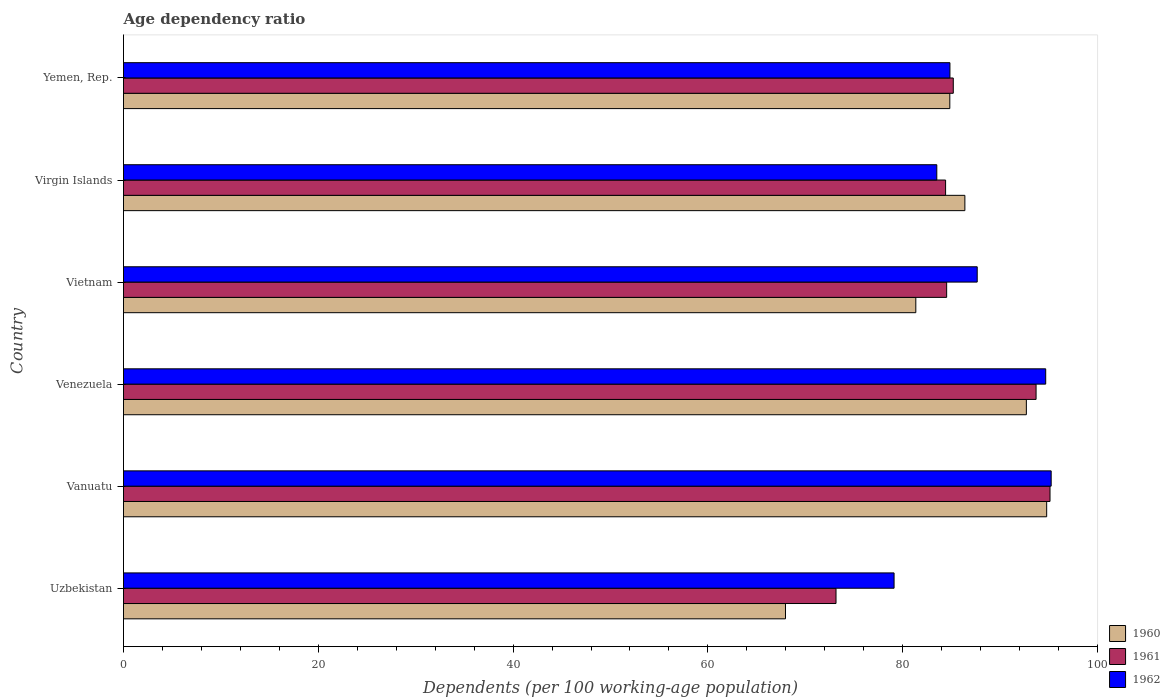How many groups of bars are there?
Your answer should be very brief. 6. Are the number of bars per tick equal to the number of legend labels?
Offer a very short reply. Yes. How many bars are there on the 2nd tick from the top?
Offer a very short reply. 3. What is the label of the 1st group of bars from the top?
Your answer should be very brief. Yemen, Rep. In how many cases, is the number of bars for a given country not equal to the number of legend labels?
Offer a very short reply. 0. What is the age dependency ratio in in 1961 in Venezuela?
Your response must be concise. 93.69. Across all countries, what is the maximum age dependency ratio in in 1961?
Provide a short and direct response. 95.12. Across all countries, what is the minimum age dependency ratio in in 1962?
Ensure brevity in your answer.  79.11. In which country was the age dependency ratio in in 1962 maximum?
Your response must be concise. Vanuatu. In which country was the age dependency ratio in in 1961 minimum?
Keep it short and to the point. Uzbekistan. What is the total age dependency ratio in in 1962 in the graph?
Your answer should be compact. 525.04. What is the difference between the age dependency ratio in in 1961 in Virgin Islands and that in Yemen, Rep.?
Your answer should be very brief. -0.79. What is the difference between the age dependency ratio in in 1961 in Virgin Islands and the age dependency ratio in in 1962 in Yemen, Rep.?
Give a very brief answer. -0.45. What is the average age dependency ratio in in 1962 per country?
Offer a very short reply. 87.51. What is the difference between the age dependency ratio in in 1960 and age dependency ratio in in 1961 in Venezuela?
Your response must be concise. -1. In how many countries, is the age dependency ratio in in 1962 greater than 12 %?
Offer a terse response. 6. What is the ratio of the age dependency ratio in in 1961 in Venezuela to that in Yemen, Rep.?
Offer a very short reply. 1.1. Is the age dependency ratio in in 1961 in Vanuatu less than that in Virgin Islands?
Make the answer very short. No. What is the difference between the highest and the second highest age dependency ratio in in 1961?
Your answer should be compact. 1.43. What is the difference between the highest and the lowest age dependency ratio in in 1960?
Make the answer very short. 26.82. In how many countries, is the age dependency ratio in in 1962 greater than the average age dependency ratio in in 1962 taken over all countries?
Give a very brief answer. 3. What does the 2nd bar from the top in Vietnam represents?
Make the answer very short. 1961. Is it the case that in every country, the sum of the age dependency ratio in in 1961 and age dependency ratio in in 1960 is greater than the age dependency ratio in in 1962?
Provide a short and direct response. Yes. How many bars are there?
Ensure brevity in your answer.  18. Are all the bars in the graph horizontal?
Ensure brevity in your answer.  Yes. What is the difference between two consecutive major ticks on the X-axis?
Provide a short and direct response. 20. Are the values on the major ticks of X-axis written in scientific E-notation?
Make the answer very short. No. Does the graph contain grids?
Your answer should be very brief. No. Where does the legend appear in the graph?
Provide a short and direct response. Bottom right. How are the legend labels stacked?
Provide a succinct answer. Vertical. What is the title of the graph?
Provide a succinct answer. Age dependency ratio. Does "2003" appear as one of the legend labels in the graph?
Make the answer very short. No. What is the label or title of the X-axis?
Offer a terse response. Dependents (per 100 working-age population). What is the Dependents (per 100 working-age population) of 1960 in Uzbekistan?
Make the answer very short. 67.97. What is the Dependents (per 100 working-age population) of 1961 in Uzbekistan?
Ensure brevity in your answer.  73.15. What is the Dependents (per 100 working-age population) in 1962 in Uzbekistan?
Give a very brief answer. 79.11. What is the Dependents (per 100 working-age population) of 1960 in Vanuatu?
Your answer should be very brief. 94.78. What is the Dependents (per 100 working-age population) in 1961 in Vanuatu?
Your answer should be very brief. 95.12. What is the Dependents (per 100 working-age population) of 1962 in Vanuatu?
Offer a very short reply. 95.24. What is the Dependents (per 100 working-age population) of 1960 in Venezuela?
Ensure brevity in your answer.  92.7. What is the Dependents (per 100 working-age population) in 1961 in Venezuela?
Provide a short and direct response. 93.69. What is the Dependents (per 100 working-age population) in 1962 in Venezuela?
Offer a terse response. 94.68. What is the Dependents (per 100 working-age population) in 1960 in Vietnam?
Ensure brevity in your answer.  81.35. What is the Dependents (per 100 working-age population) of 1961 in Vietnam?
Provide a short and direct response. 84.51. What is the Dependents (per 100 working-age population) of 1962 in Vietnam?
Provide a short and direct response. 87.65. What is the Dependents (per 100 working-age population) of 1960 in Virgin Islands?
Provide a succinct answer. 86.38. What is the Dependents (per 100 working-age population) of 1961 in Virgin Islands?
Give a very brief answer. 84.4. What is the Dependents (per 100 working-age population) of 1962 in Virgin Islands?
Your answer should be compact. 83.5. What is the Dependents (per 100 working-age population) in 1960 in Yemen, Rep.?
Offer a terse response. 84.84. What is the Dependents (per 100 working-age population) of 1961 in Yemen, Rep.?
Your response must be concise. 85.19. What is the Dependents (per 100 working-age population) of 1962 in Yemen, Rep.?
Your answer should be very brief. 84.85. Across all countries, what is the maximum Dependents (per 100 working-age population) in 1960?
Your answer should be very brief. 94.78. Across all countries, what is the maximum Dependents (per 100 working-age population) in 1961?
Give a very brief answer. 95.12. Across all countries, what is the maximum Dependents (per 100 working-age population) in 1962?
Keep it short and to the point. 95.24. Across all countries, what is the minimum Dependents (per 100 working-age population) of 1960?
Offer a very short reply. 67.97. Across all countries, what is the minimum Dependents (per 100 working-age population) of 1961?
Make the answer very short. 73.15. Across all countries, what is the minimum Dependents (per 100 working-age population) of 1962?
Your response must be concise. 79.11. What is the total Dependents (per 100 working-age population) of 1960 in the graph?
Offer a terse response. 508.01. What is the total Dependents (per 100 working-age population) in 1961 in the graph?
Give a very brief answer. 516.08. What is the total Dependents (per 100 working-age population) in 1962 in the graph?
Your answer should be compact. 525.04. What is the difference between the Dependents (per 100 working-age population) in 1960 in Uzbekistan and that in Vanuatu?
Keep it short and to the point. -26.82. What is the difference between the Dependents (per 100 working-age population) of 1961 in Uzbekistan and that in Vanuatu?
Keep it short and to the point. -21.97. What is the difference between the Dependents (per 100 working-age population) in 1962 in Uzbekistan and that in Vanuatu?
Your answer should be compact. -16.13. What is the difference between the Dependents (per 100 working-age population) in 1960 in Uzbekistan and that in Venezuela?
Your answer should be compact. -24.73. What is the difference between the Dependents (per 100 working-age population) in 1961 in Uzbekistan and that in Venezuela?
Your response must be concise. -20.54. What is the difference between the Dependents (per 100 working-age population) in 1962 in Uzbekistan and that in Venezuela?
Offer a terse response. -15.57. What is the difference between the Dependents (per 100 working-age population) in 1960 in Uzbekistan and that in Vietnam?
Keep it short and to the point. -13.38. What is the difference between the Dependents (per 100 working-age population) in 1961 in Uzbekistan and that in Vietnam?
Make the answer very short. -11.36. What is the difference between the Dependents (per 100 working-age population) of 1962 in Uzbekistan and that in Vietnam?
Offer a terse response. -8.54. What is the difference between the Dependents (per 100 working-age population) in 1960 in Uzbekistan and that in Virgin Islands?
Provide a short and direct response. -18.42. What is the difference between the Dependents (per 100 working-age population) in 1961 in Uzbekistan and that in Virgin Islands?
Your answer should be very brief. -11.25. What is the difference between the Dependents (per 100 working-age population) in 1962 in Uzbekistan and that in Virgin Islands?
Offer a very short reply. -4.39. What is the difference between the Dependents (per 100 working-age population) of 1960 in Uzbekistan and that in Yemen, Rep.?
Your answer should be very brief. -16.87. What is the difference between the Dependents (per 100 working-age population) in 1961 in Uzbekistan and that in Yemen, Rep.?
Provide a short and direct response. -12.04. What is the difference between the Dependents (per 100 working-age population) in 1962 in Uzbekistan and that in Yemen, Rep.?
Provide a short and direct response. -5.74. What is the difference between the Dependents (per 100 working-age population) of 1960 in Vanuatu and that in Venezuela?
Your answer should be compact. 2.08. What is the difference between the Dependents (per 100 working-age population) of 1961 in Vanuatu and that in Venezuela?
Provide a succinct answer. 1.43. What is the difference between the Dependents (per 100 working-age population) of 1962 in Vanuatu and that in Venezuela?
Give a very brief answer. 0.56. What is the difference between the Dependents (per 100 working-age population) of 1960 in Vanuatu and that in Vietnam?
Keep it short and to the point. 13.43. What is the difference between the Dependents (per 100 working-age population) of 1961 in Vanuatu and that in Vietnam?
Keep it short and to the point. 10.61. What is the difference between the Dependents (per 100 working-age population) of 1962 in Vanuatu and that in Vietnam?
Provide a short and direct response. 7.59. What is the difference between the Dependents (per 100 working-age population) of 1960 in Vanuatu and that in Virgin Islands?
Make the answer very short. 8.4. What is the difference between the Dependents (per 100 working-age population) of 1961 in Vanuatu and that in Virgin Islands?
Your response must be concise. 10.72. What is the difference between the Dependents (per 100 working-age population) in 1962 in Vanuatu and that in Virgin Islands?
Offer a terse response. 11.74. What is the difference between the Dependents (per 100 working-age population) in 1960 in Vanuatu and that in Yemen, Rep.?
Your answer should be compact. 9.94. What is the difference between the Dependents (per 100 working-age population) in 1961 in Vanuatu and that in Yemen, Rep.?
Your response must be concise. 9.93. What is the difference between the Dependents (per 100 working-age population) in 1962 in Vanuatu and that in Yemen, Rep.?
Offer a terse response. 10.39. What is the difference between the Dependents (per 100 working-age population) of 1960 in Venezuela and that in Vietnam?
Your response must be concise. 11.35. What is the difference between the Dependents (per 100 working-age population) of 1961 in Venezuela and that in Vietnam?
Your answer should be very brief. 9.18. What is the difference between the Dependents (per 100 working-age population) of 1962 in Venezuela and that in Vietnam?
Your answer should be very brief. 7.03. What is the difference between the Dependents (per 100 working-age population) in 1960 in Venezuela and that in Virgin Islands?
Your response must be concise. 6.31. What is the difference between the Dependents (per 100 working-age population) of 1961 in Venezuela and that in Virgin Islands?
Your response must be concise. 9.29. What is the difference between the Dependents (per 100 working-age population) in 1962 in Venezuela and that in Virgin Islands?
Provide a succinct answer. 11.18. What is the difference between the Dependents (per 100 working-age population) of 1960 in Venezuela and that in Yemen, Rep.?
Provide a short and direct response. 7.86. What is the difference between the Dependents (per 100 working-age population) in 1961 in Venezuela and that in Yemen, Rep.?
Make the answer very short. 8.5. What is the difference between the Dependents (per 100 working-age population) of 1962 in Venezuela and that in Yemen, Rep.?
Provide a short and direct response. 9.83. What is the difference between the Dependents (per 100 working-age population) of 1960 in Vietnam and that in Virgin Islands?
Make the answer very short. -5.04. What is the difference between the Dependents (per 100 working-age population) of 1961 in Vietnam and that in Virgin Islands?
Give a very brief answer. 0.11. What is the difference between the Dependents (per 100 working-age population) of 1962 in Vietnam and that in Virgin Islands?
Keep it short and to the point. 4.15. What is the difference between the Dependents (per 100 working-age population) of 1960 in Vietnam and that in Yemen, Rep.?
Your answer should be very brief. -3.49. What is the difference between the Dependents (per 100 working-age population) in 1961 in Vietnam and that in Yemen, Rep.?
Provide a succinct answer. -0.68. What is the difference between the Dependents (per 100 working-age population) of 1962 in Vietnam and that in Yemen, Rep.?
Offer a very short reply. 2.8. What is the difference between the Dependents (per 100 working-age population) in 1960 in Virgin Islands and that in Yemen, Rep.?
Provide a succinct answer. 1.55. What is the difference between the Dependents (per 100 working-age population) in 1961 in Virgin Islands and that in Yemen, Rep.?
Provide a succinct answer. -0.79. What is the difference between the Dependents (per 100 working-age population) in 1962 in Virgin Islands and that in Yemen, Rep.?
Provide a short and direct response. -1.35. What is the difference between the Dependents (per 100 working-age population) of 1960 in Uzbekistan and the Dependents (per 100 working-age population) of 1961 in Vanuatu?
Give a very brief answer. -27.16. What is the difference between the Dependents (per 100 working-age population) of 1960 in Uzbekistan and the Dependents (per 100 working-age population) of 1962 in Vanuatu?
Give a very brief answer. -27.28. What is the difference between the Dependents (per 100 working-age population) of 1961 in Uzbekistan and the Dependents (per 100 working-age population) of 1962 in Vanuatu?
Ensure brevity in your answer.  -22.09. What is the difference between the Dependents (per 100 working-age population) in 1960 in Uzbekistan and the Dependents (per 100 working-age population) in 1961 in Venezuela?
Give a very brief answer. -25.73. What is the difference between the Dependents (per 100 working-age population) in 1960 in Uzbekistan and the Dependents (per 100 working-age population) in 1962 in Venezuela?
Provide a short and direct response. -26.72. What is the difference between the Dependents (per 100 working-age population) in 1961 in Uzbekistan and the Dependents (per 100 working-age population) in 1962 in Venezuela?
Keep it short and to the point. -21.53. What is the difference between the Dependents (per 100 working-age population) in 1960 in Uzbekistan and the Dependents (per 100 working-age population) in 1961 in Vietnam?
Offer a terse response. -16.55. What is the difference between the Dependents (per 100 working-age population) in 1960 in Uzbekistan and the Dependents (per 100 working-age population) in 1962 in Vietnam?
Ensure brevity in your answer.  -19.68. What is the difference between the Dependents (per 100 working-age population) in 1961 in Uzbekistan and the Dependents (per 100 working-age population) in 1962 in Vietnam?
Offer a very short reply. -14.5. What is the difference between the Dependents (per 100 working-age population) of 1960 in Uzbekistan and the Dependents (per 100 working-age population) of 1961 in Virgin Islands?
Provide a short and direct response. -16.44. What is the difference between the Dependents (per 100 working-age population) in 1960 in Uzbekistan and the Dependents (per 100 working-age population) in 1962 in Virgin Islands?
Provide a short and direct response. -15.53. What is the difference between the Dependents (per 100 working-age population) of 1961 in Uzbekistan and the Dependents (per 100 working-age population) of 1962 in Virgin Islands?
Give a very brief answer. -10.35. What is the difference between the Dependents (per 100 working-age population) of 1960 in Uzbekistan and the Dependents (per 100 working-age population) of 1961 in Yemen, Rep.?
Provide a succinct answer. -17.23. What is the difference between the Dependents (per 100 working-age population) in 1960 in Uzbekistan and the Dependents (per 100 working-age population) in 1962 in Yemen, Rep.?
Your response must be concise. -16.89. What is the difference between the Dependents (per 100 working-age population) of 1961 in Uzbekistan and the Dependents (per 100 working-age population) of 1962 in Yemen, Rep.?
Give a very brief answer. -11.7. What is the difference between the Dependents (per 100 working-age population) of 1960 in Vanuatu and the Dependents (per 100 working-age population) of 1961 in Venezuela?
Ensure brevity in your answer.  1.09. What is the difference between the Dependents (per 100 working-age population) in 1960 in Vanuatu and the Dependents (per 100 working-age population) in 1962 in Venezuela?
Offer a very short reply. 0.1. What is the difference between the Dependents (per 100 working-age population) of 1961 in Vanuatu and the Dependents (per 100 working-age population) of 1962 in Venezuela?
Make the answer very short. 0.44. What is the difference between the Dependents (per 100 working-age population) of 1960 in Vanuatu and the Dependents (per 100 working-age population) of 1961 in Vietnam?
Give a very brief answer. 10.27. What is the difference between the Dependents (per 100 working-age population) of 1960 in Vanuatu and the Dependents (per 100 working-age population) of 1962 in Vietnam?
Provide a short and direct response. 7.13. What is the difference between the Dependents (per 100 working-age population) of 1961 in Vanuatu and the Dependents (per 100 working-age population) of 1962 in Vietnam?
Keep it short and to the point. 7.47. What is the difference between the Dependents (per 100 working-age population) of 1960 in Vanuatu and the Dependents (per 100 working-age population) of 1961 in Virgin Islands?
Make the answer very short. 10.38. What is the difference between the Dependents (per 100 working-age population) in 1960 in Vanuatu and the Dependents (per 100 working-age population) in 1962 in Virgin Islands?
Your answer should be very brief. 11.28. What is the difference between the Dependents (per 100 working-age population) in 1961 in Vanuatu and the Dependents (per 100 working-age population) in 1962 in Virgin Islands?
Provide a short and direct response. 11.62. What is the difference between the Dependents (per 100 working-age population) in 1960 in Vanuatu and the Dependents (per 100 working-age population) in 1961 in Yemen, Rep.?
Offer a very short reply. 9.59. What is the difference between the Dependents (per 100 working-age population) in 1960 in Vanuatu and the Dependents (per 100 working-age population) in 1962 in Yemen, Rep.?
Offer a very short reply. 9.93. What is the difference between the Dependents (per 100 working-age population) in 1961 in Vanuatu and the Dependents (per 100 working-age population) in 1962 in Yemen, Rep.?
Provide a short and direct response. 10.27. What is the difference between the Dependents (per 100 working-age population) in 1960 in Venezuela and the Dependents (per 100 working-age population) in 1961 in Vietnam?
Offer a terse response. 8.18. What is the difference between the Dependents (per 100 working-age population) in 1960 in Venezuela and the Dependents (per 100 working-age population) in 1962 in Vietnam?
Offer a terse response. 5.05. What is the difference between the Dependents (per 100 working-age population) of 1961 in Venezuela and the Dependents (per 100 working-age population) of 1962 in Vietnam?
Provide a succinct answer. 6.04. What is the difference between the Dependents (per 100 working-age population) in 1960 in Venezuela and the Dependents (per 100 working-age population) in 1961 in Virgin Islands?
Give a very brief answer. 8.29. What is the difference between the Dependents (per 100 working-age population) in 1960 in Venezuela and the Dependents (per 100 working-age population) in 1962 in Virgin Islands?
Your answer should be very brief. 9.2. What is the difference between the Dependents (per 100 working-age population) in 1961 in Venezuela and the Dependents (per 100 working-age population) in 1962 in Virgin Islands?
Your response must be concise. 10.19. What is the difference between the Dependents (per 100 working-age population) of 1960 in Venezuela and the Dependents (per 100 working-age population) of 1961 in Yemen, Rep.?
Provide a succinct answer. 7.5. What is the difference between the Dependents (per 100 working-age population) in 1960 in Venezuela and the Dependents (per 100 working-age population) in 1962 in Yemen, Rep.?
Offer a terse response. 7.85. What is the difference between the Dependents (per 100 working-age population) in 1961 in Venezuela and the Dependents (per 100 working-age population) in 1962 in Yemen, Rep.?
Provide a succinct answer. 8.84. What is the difference between the Dependents (per 100 working-age population) of 1960 in Vietnam and the Dependents (per 100 working-age population) of 1961 in Virgin Islands?
Your response must be concise. -3.06. What is the difference between the Dependents (per 100 working-age population) in 1960 in Vietnam and the Dependents (per 100 working-age population) in 1962 in Virgin Islands?
Your response must be concise. -2.15. What is the difference between the Dependents (per 100 working-age population) of 1961 in Vietnam and the Dependents (per 100 working-age population) of 1962 in Virgin Islands?
Give a very brief answer. 1.01. What is the difference between the Dependents (per 100 working-age population) of 1960 in Vietnam and the Dependents (per 100 working-age population) of 1961 in Yemen, Rep.?
Your response must be concise. -3.85. What is the difference between the Dependents (per 100 working-age population) of 1960 in Vietnam and the Dependents (per 100 working-age population) of 1962 in Yemen, Rep.?
Your answer should be very brief. -3.5. What is the difference between the Dependents (per 100 working-age population) in 1961 in Vietnam and the Dependents (per 100 working-age population) in 1962 in Yemen, Rep.?
Give a very brief answer. -0.34. What is the difference between the Dependents (per 100 working-age population) of 1960 in Virgin Islands and the Dependents (per 100 working-age population) of 1961 in Yemen, Rep.?
Provide a short and direct response. 1.19. What is the difference between the Dependents (per 100 working-age population) in 1960 in Virgin Islands and the Dependents (per 100 working-age population) in 1962 in Yemen, Rep.?
Ensure brevity in your answer.  1.53. What is the difference between the Dependents (per 100 working-age population) in 1961 in Virgin Islands and the Dependents (per 100 working-age population) in 1962 in Yemen, Rep.?
Your response must be concise. -0.45. What is the average Dependents (per 100 working-age population) in 1960 per country?
Your response must be concise. 84.67. What is the average Dependents (per 100 working-age population) in 1961 per country?
Keep it short and to the point. 86.01. What is the average Dependents (per 100 working-age population) in 1962 per country?
Your response must be concise. 87.51. What is the difference between the Dependents (per 100 working-age population) of 1960 and Dependents (per 100 working-age population) of 1961 in Uzbekistan?
Provide a short and direct response. -5.19. What is the difference between the Dependents (per 100 working-age population) in 1960 and Dependents (per 100 working-age population) in 1962 in Uzbekistan?
Give a very brief answer. -11.15. What is the difference between the Dependents (per 100 working-age population) of 1961 and Dependents (per 100 working-age population) of 1962 in Uzbekistan?
Offer a very short reply. -5.96. What is the difference between the Dependents (per 100 working-age population) of 1960 and Dependents (per 100 working-age population) of 1961 in Vanuatu?
Give a very brief answer. -0.34. What is the difference between the Dependents (per 100 working-age population) of 1960 and Dependents (per 100 working-age population) of 1962 in Vanuatu?
Give a very brief answer. -0.46. What is the difference between the Dependents (per 100 working-age population) of 1961 and Dependents (per 100 working-age population) of 1962 in Vanuatu?
Offer a very short reply. -0.12. What is the difference between the Dependents (per 100 working-age population) of 1960 and Dependents (per 100 working-age population) of 1961 in Venezuela?
Your answer should be very brief. -1. What is the difference between the Dependents (per 100 working-age population) of 1960 and Dependents (per 100 working-age population) of 1962 in Venezuela?
Make the answer very short. -1.99. What is the difference between the Dependents (per 100 working-age population) in 1961 and Dependents (per 100 working-age population) in 1962 in Venezuela?
Provide a succinct answer. -0.99. What is the difference between the Dependents (per 100 working-age population) of 1960 and Dependents (per 100 working-age population) of 1961 in Vietnam?
Make the answer very short. -3.17. What is the difference between the Dependents (per 100 working-age population) of 1960 and Dependents (per 100 working-age population) of 1962 in Vietnam?
Make the answer very short. -6.3. What is the difference between the Dependents (per 100 working-age population) of 1961 and Dependents (per 100 working-age population) of 1962 in Vietnam?
Your answer should be compact. -3.14. What is the difference between the Dependents (per 100 working-age population) of 1960 and Dependents (per 100 working-age population) of 1961 in Virgin Islands?
Your response must be concise. 1.98. What is the difference between the Dependents (per 100 working-age population) in 1960 and Dependents (per 100 working-age population) in 1962 in Virgin Islands?
Give a very brief answer. 2.88. What is the difference between the Dependents (per 100 working-age population) in 1961 and Dependents (per 100 working-age population) in 1962 in Virgin Islands?
Offer a very short reply. 0.9. What is the difference between the Dependents (per 100 working-age population) of 1960 and Dependents (per 100 working-age population) of 1961 in Yemen, Rep.?
Give a very brief answer. -0.36. What is the difference between the Dependents (per 100 working-age population) in 1960 and Dependents (per 100 working-age population) in 1962 in Yemen, Rep.?
Your response must be concise. -0.01. What is the difference between the Dependents (per 100 working-age population) in 1961 and Dependents (per 100 working-age population) in 1962 in Yemen, Rep.?
Provide a succinct answer. 0.34. What is the ratio of the Dependents (per 100 working-age population) of 1960 in Uzbekistan to that in Vanuatu?
Your response must be concise. 0.72. What is the ratio of the Dependents (per 100 working-age population) of 1961 in Uzbekistan to that in Vanuatu?
Your answer should be very brief. 0.77. What is the ratio of the Dependents (per 100 working-age population) in 1962 in Uzbekistan to that in Vanuatu?
Your answer should be compact. 0.83. What is the ratio of the Dependents (per 100 working-age population) of 1960 in Uzbekistan to that in Venezuela?
Give a very brief answer. 0.73. What is the ratio of the Dependents (per 100 working-age population) of 1961 in Uzbekistan to that in Venezuela?
Keep it short and to the point. 0.78. What is the ratio of the Dependents (per 100 working-age population) in 1962 in Uzbekistan to that in Venezuela?
Your response must be concise. 0.84. What is the ratio of the Dependents (per 100 working-age population) of 1960 in Uzbekistan to that in Vietnam?
Offer a very short reply. 0.84. What is the ratio of the Dependents (per 100 working-age population) of 1961 in Uzbekistan to that in Vietnam?
Ensure brevity in your answer.  0.87. What is the ratio of the Dependents (per 100 working-age population) of 1962 in Uzbekistan to that in Vietnam?
Your response must be concise. 0.9. What is the ratio of the Dependents (per 100 working-age population) of 1960 in Uzbekistan to that in Virgin Islands?
Make the answer very short. 0.79. What is the ratio of the Dependents (per 100 working-age population) in 1961 in Uzbekistan to that in Virgin Islands?
Your answer should be very brief. 0.87. What is the ratio of the Dependents (per 100 working-age population) in 1962 in Uzbekistan to that in Virgin Islands?
Provide a short and direct response. 0.95. What is the ratio of the Dependents (per 100 working-age population) of 1960 in Uzbekistan to that in Yemen, Rep.?
Ensure brevity in your answer.  0.8. What is the ratio of the Dependents (per 100 working-age population) of 1961 in Uzbekistan to that in Yemen, Rep.?
Your answer should be compact. 0.86. What is the ratio of the Dependents (per 100 working-age population) in 1962 in Uzbekistan to that in Yemen, Rep.?
Make the answer very short. 0.93. What is the ratio of the Dependents (per 100 working-age population) of 1960 in Vanuatu to that in Venezuela?
Give a very brief answer. 1.02. What is the ratio of the Dependents (per 100 working-age population) in 1961 in Vanuatu to that in Venezuela?
Ensure brevity in your answer.  1.02. What is the ratio of the Dependents (per 100 working-age population) in 1962 in Vanuatu to that in Venezuela?
Provide a short and direct response. 1.01. What is the ratio of the Dependents (per 100 working-age population) in 1960 in Vanuatu to that in Vietnam?
Your response must be concise. 1.17. What is the ratio of the Dependents (per 100 working-age population) of 1961 in Vanuatu to that in Vietnam?
Offer a terse response. 1.13. What is the ratio of the Dependents (per 100 working-age population) in 1962 in Vanuatu to that in Vietnam?
Provide a short and direct response. 1.09. What is the ratio of the Dependents (per 100 working-age population) in 1960 in Vanuatu to that in Virgin Islands?
Make the answer very short. 1.1. What is the ratio of the Dependents (per 100 working-age population) in 1961 in Vanuatu to that in Virgin Islands?
Keep it short and to the point. 1.13. What is the ratio of the Dependents (per 100 working-age population) of 1962 in Vanuatu to that in Virgin Islands?
Offer a terse response. 1.14. What is the ratio of the Dependents (per 100 working-age population) of 1960 in Vanuatu to that in Yemen, Rep.?
Offer a very short reply. 1.12. What is the ratio of the Dependents (per 100 working-age population) of 1961 in Vanuatu to that in Yemen, Rep.?
Make the answer very short. 1.12. What is the ratio of the Dependents (per 100 working-age population) of 1962 in Vanuatu to that in Yemen, Rep.?
Offer a very short reply. 1.12. What is the ratio of the Dependents (per 100 working-age population) in 1960 in Venezuela to that in Vietnam?
Offer a terse response. 1.14. What is the ratio of the Dependents (per 100 working-age population) in 1961 in Venezuela to that in Vietnam?
Provide a succinct answer. 1.11. What is the ratio of the Dependents (per 100 working-age population) in 1962 in Venezuela to that in Vietnam?
Keep it short and to the point. 1.08. What is the ratio of the Dependents (per 100 working-age population) in 1960 in Venezuela to that in Virgin Islands?
Give a very brief answer. 1.07. What is the ratio of the Dependents (per 100 working-age population) of 1961 in Venezuela to that in Virgin Islands?
Ensure brevity in your answer.  1.11. What is the ratio of the Dependents (per 100 working-age population) in 1962 in Venezuela to that in Virgin Islands?
Give a very brief answer. 1.13. What is the ratio of the Dependents (per 100 working-age population) of 1960 in Venezuela to that in Yemen, Rep.?
Offer a terse response. 1.09. What is the ratio of the Dependents (per 100 working-age population) in 1961 in Venezuela to that in Yemen, Rep.?
Offer a terse response. 1.1. What is the ratio of the Dependents (per 100 working-age population) in 1962 in Venezuela to that in Yemen, Rep.?
Keep it short and to the point. 1.12. What is the ratio of the Dependents (per 100 working-age population) in 1960 in Vietnam to that in Virgin Islands?
Offer a very short reply. 0.94. What is the ratio of the Dependents (per 100 working-age population) of 1961 in Vietnam to that in Virgin Islands?
Keep it short and to the point. 1. What is the ratio of the Dependents (per 100 working-age population) of 1962 in Vietnam to that in Virgin Islands?
Provide a succinct answer. 1.05. What is the ratio of the Dependents (per 100 working-age population) of 1960 in Vietnam to that in Yemen, Rep.?
Offer a very short reply. 0.96. What is the ratio of the Dependents (per 100 working-age population) in 1961 in Vietnam to that in Yemen, Rep.?
Keep it short and to the point. 0.99. What is the ratio of the Dependents (per 100 working-age population) of 1962 in Vietnam to that in Yemen, Rep.?
Ensure brevity in your answer.  1.03. What is the ratio of the Dependents (per 100 working-age population) in 1960 in Virgin Islands to that in Yemen, Rep.?
Your answer should be compact. 1.02. What is the ratio of the Dependents (per 100 working-age population) of 1962 in Virgin Islands to that in Yemen, Rep.?
Your answer should be very brief. 0.98. What is the difference between the highest and the second highest Dependents (per 100 working-age population) of 1960?
Offer a terse response. 2.08. What is the difference between the highest and the second highest Dependents (per 100 working-age population) in 1961?
Your response must be concise. 1.43. What is the difference between the highest and the second highest Dependents (per 100 working-age population) in 1962?
Offer a very short reply. 0.56. What is the difference between the highest and the lowest Dependents (per 100 working-age population) in 1960?
Provide a succinct answer. 26.82. What is the difference between the highest and the lowest Dependents (per 100 working-age population) of 1961?
Provide a succinct answer. 21.97. What is the difference between the highest and the lowest Dependents (per 100 working-age population) of 1962?
Give a very brief answer. 16.13. 